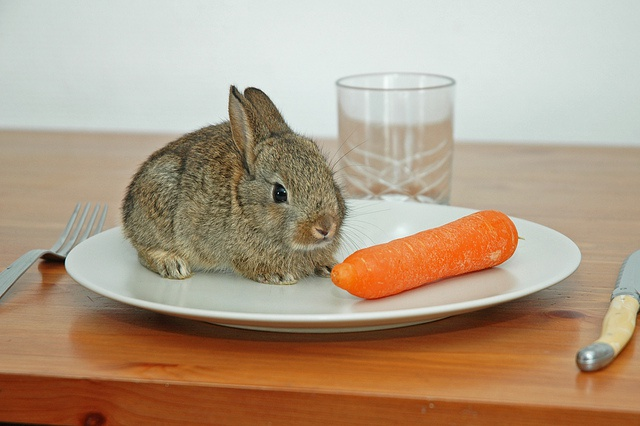Describe the objects in this image and their specific colors. I can see dining table in lightgray, tan, brown, and maroon tones, cup in lightgray, darkgray, and tan tones, carrot in lightgray, red, orange, and salmon tones, knife in lightgray, darkgray, tan, and gray tones, and fork in lightgray, darkgray, gray, and black tones in this image. 